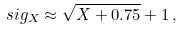<formula> <loc_0><loc_0><loc_500><loc_500>\ s i g _ { X } \approx \sqrt { X + 0 . 7 5 } + 1 \, ,</formula> 